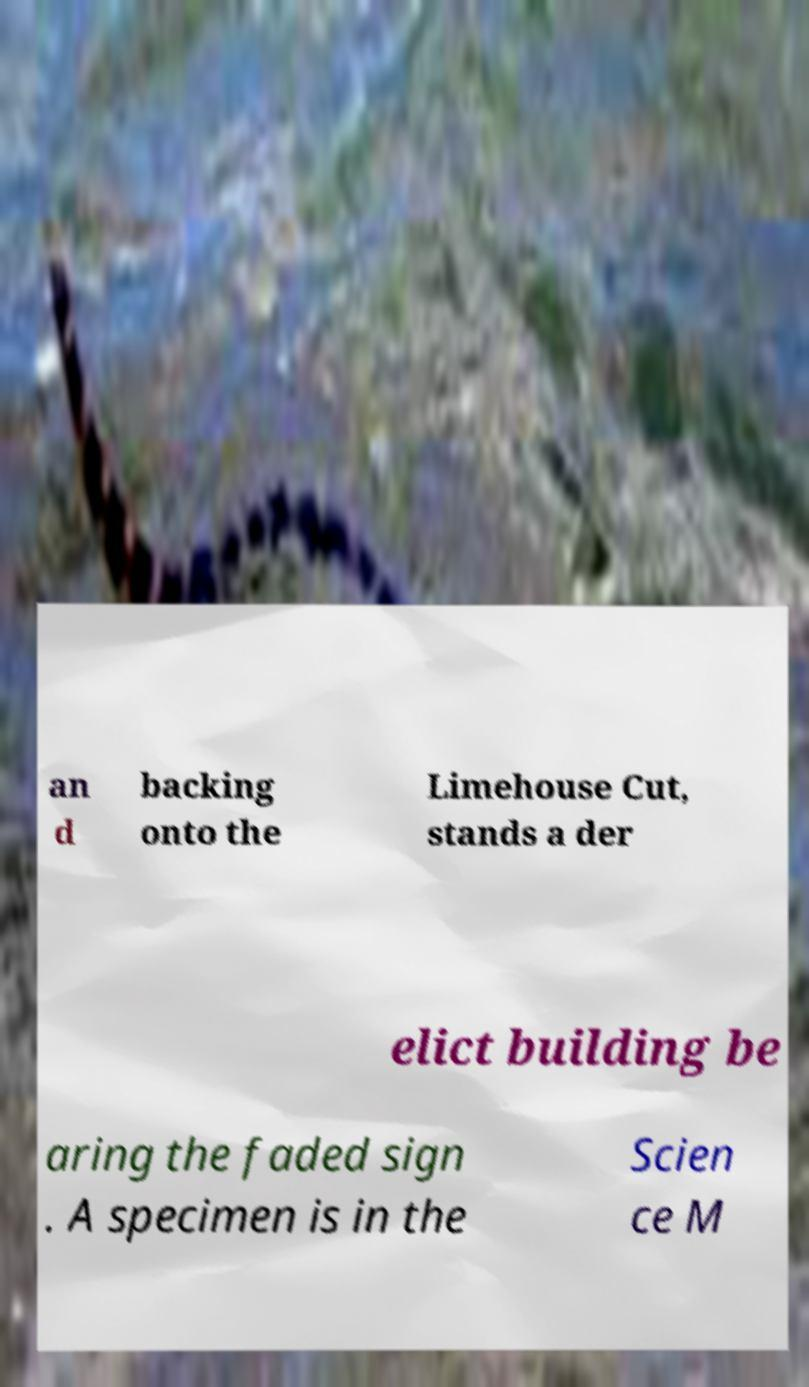What messages or text are displayed in this image? I need them in a readable, typed format. an d backing onto the Limehouse Cut, stands a der elict building be aring the faded sign . A specimen is in the Scien ce M 